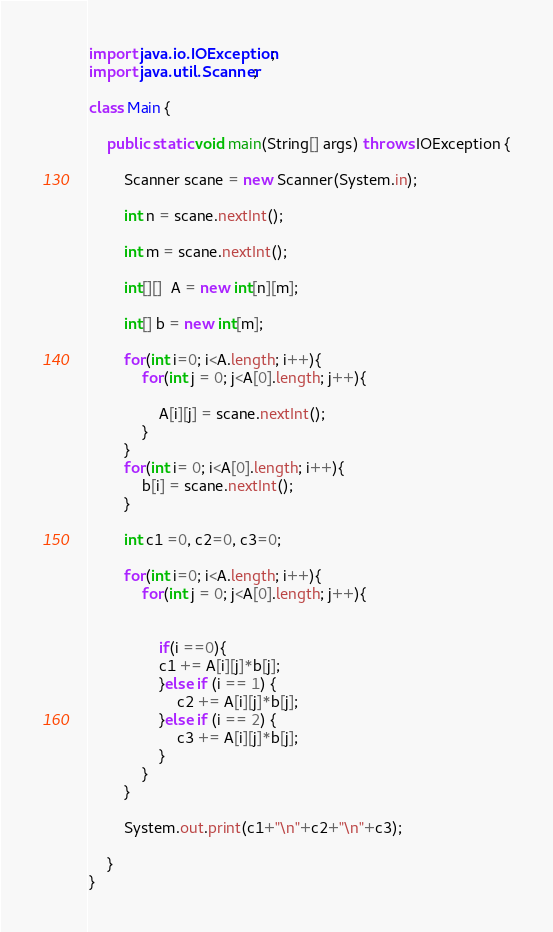<code> <loc_0><loc_0><loc_500><loc_500><_Java_>import java.io.IOException;
import java.util.Scanner;

class Main {

	public static void main(String[] args) throws IOException {

		Scanner scane = new Scanner(System.in);

		int n = scane.nextInt();

		int m = scane.nextInt();

		int[][]  A = new int[n][m];

		int[] b = new int[m];

		for(int i=0; i<A.length; i++){
			for(int j = 0; j<A[0].length; j++){

				A[i][j] = scane.nextInt();
			}
		}
		for(int i= 0; i<A[0].length; i++){
			b[i] = scane.nextInt();
		}

		int c1 =0, c2=0, c3=0;

		for(int i=0; i<A.length; i++){
			for(int j = 0; j<A[0].length; j++){


				if(i ==0){
				c1 += A[i][j]*b[j];
				}else if (i == 1) {
					c2 += A[i][j]*b[j];
				}else if (i == 2) {
					c3 += A[i][j]*b[j];
				}
			}
		}

		System.out.print(c1+"\n"+c2+"\n"+c3);

	}
}</code> 